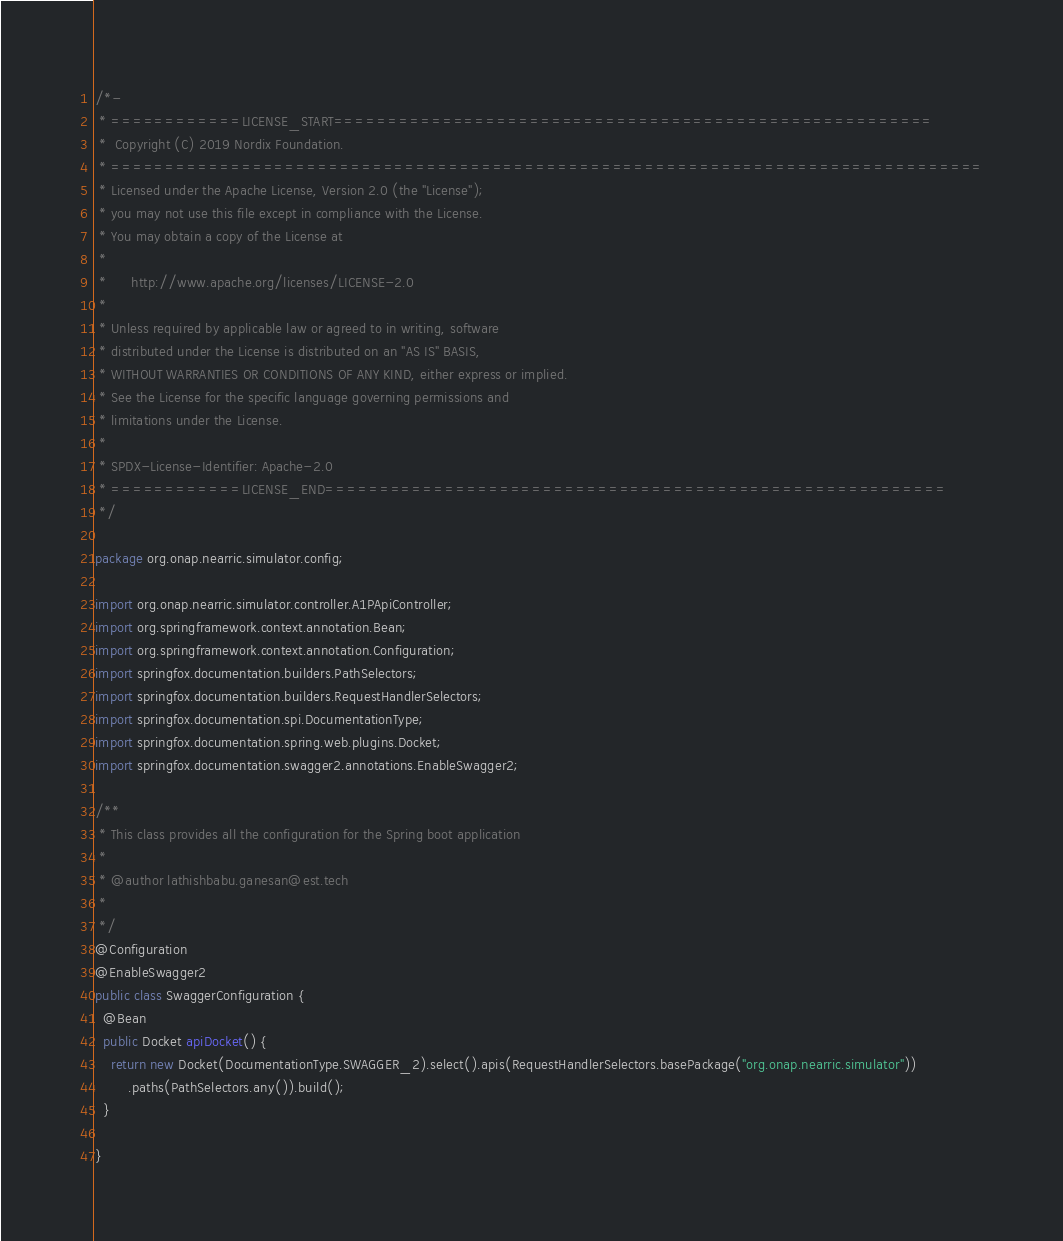<code> <loc_0><loc_0><loc_500><loc_500><_Java_>/*-
 * ============LICENSE_START=======================================================
 *  Copyright (C) 2019 Nordix Foundation.
 * ================================================================================
 * Licensed under the Apache License, Version 2.0 (the "License");
 * you may not use this file except in compliance with the License.
 * You may obtain a copy of the License at
 *
 *      http://www.apache.org/licenses/LICENSE-2.0
 *
 * Unless required by applicable law or agreed to in writing, software
 * distributed under the License is distributed on an "AS IS" BASIS,
 * WITHOUT WARRANTIES OR CONDITIONS OF ANY KIND, either express or implied.
 * See the License for the specific language governing permissions and
 * limitations under the License.
 *
 * SPDX-License-Identifier: Apache-2.0
 * ============LICENSE_END=========================================================
 */

package org.onap.nearric.simulator.config;

import org.onap.nearric.simulator.controller.A1PApiController;
import org.springframework.context.annotation.Bean;
import org.springframework.context.annotation.Configuration;
import springfox.documentation.builders.PathSelectors;
import springfox.documentation.builders.RequestHandlerSelectors;
import springfox.documentation.spi.DocumentationType;
import springfox.documentation.spring.web.plugins.Docket;
import springfox.documentation.swagger2.annotations.EnableSwagger2;

/**
 * This class provides all the configuration for the Spring boot application
 * 
 * @author lathishbabu.ganesan@est.tech
 *
 */
@Configuration
@EnableSwagger2
public class SwaggerConfiguration {
  @Bean
  public Docket apiDocket() {
    return new Docket(DocumentationType.SWAGGER_2).select().apis(RequestHandlerSelectors.basePackage("org.onap.nearric.simulator"))
        .paths(PathSelectors.any()).build();
  }

}
</code> 